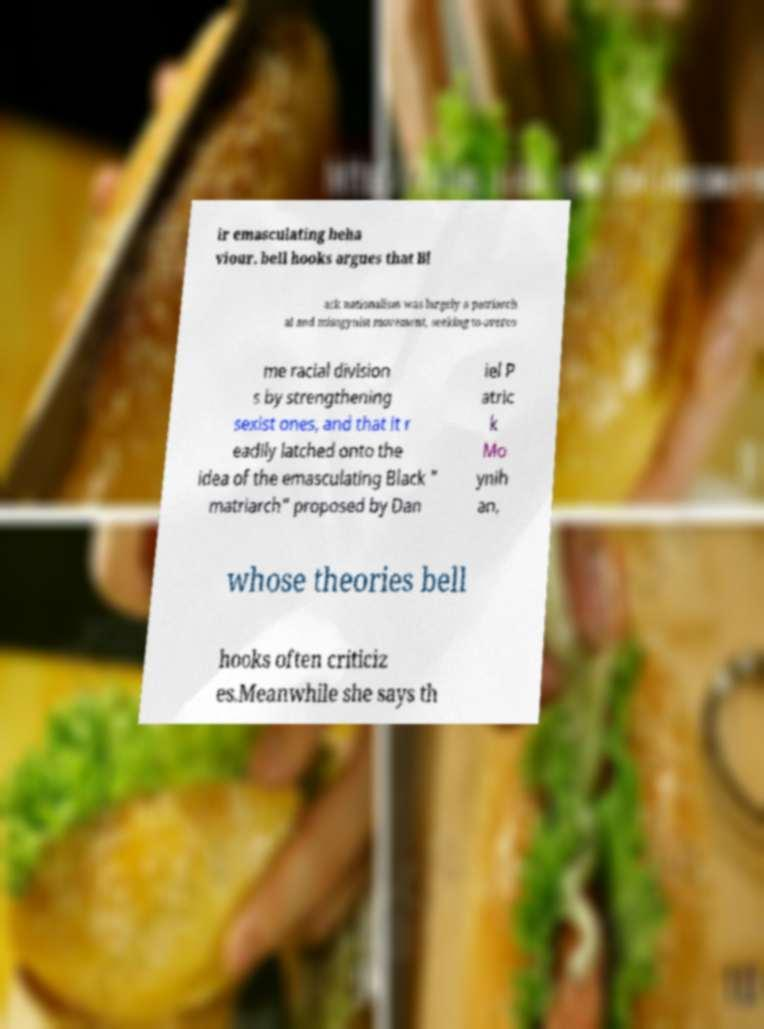Could you extract and type out the text from this image? ir emasculating beha viour. bell hooks argues that Bl ack nationalism was largely a patriarch al and misogynist movement, seeking to overco me racial division s by strengthening sexist ones, and that it r eadily latched onto the idea of the emasculating Black " matriarch" proposed by Dan iel P atric k Mo ynih an, whose theories bell hooks often criticiz es.Meanwhile she says th 